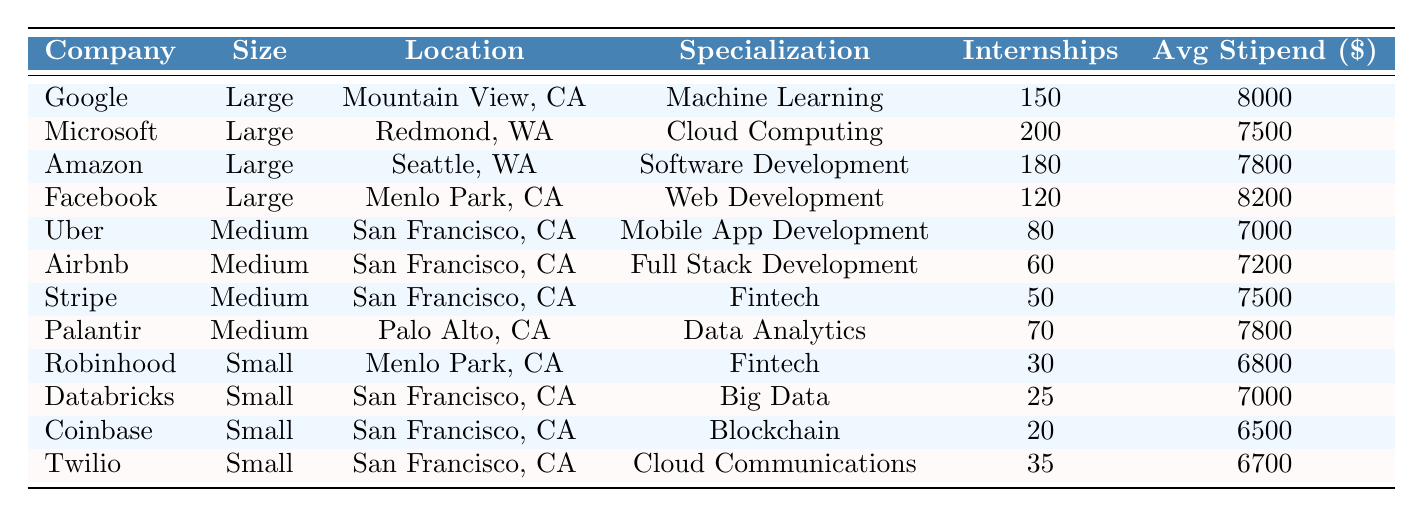What is the location of Microsoft? The table lists Microsoft as having a location in Redmond, WA.
Answer: Redmond, WA How many internships are available at Google? From the table, Google has 150 internships available.
Answer: 150 Which company has the highest average stipend? By checking the avg stipend column, Facebook has the highest stipend at $8200.
Answer: Facebook How many internships are offered by small companies in total? Adding the internships available by small companies: Robinhood (30) + Databricks (25) + Coinbase (20) + Twilio (35) = 110.
Answer: 110 Is there any company that specializes in both Fintech and is considered small? The table shows that Robinhood and Stripe are both small companies in Fintech.
Answer: Yes Which large company has the lowest average stipend? Comparing the average stipends of large companies, Microsoft has the lowest at $7500.
Answer: Microsoft What is the total number of internships available for medium-sized companies? The total for medium companies is Uber (80) + Airbnb (60) + Stripe (50) + Palantir (70) = 260 internships.
Answer: 260 What is the average stipend for internships in San Francisco? The companies located in San Francisco are Uber ($7000), Airbnb ($7200), Stripe ($7500), Databricks ($7000), Coinbase ($6500), and Twilio ($6700). The average is (7000 + 7200 + 7500 + 7000 + 6500 + 6700) / 6 = 6944.
Answer: 6944 Which location has the highest number of available internships? By checking the internship counts, Redmond (Microsoft) has the highest at 200.
Answer: Redmond, WA Is it true that all companies located in San Francisco are medium-sized? By examining the table, we see that not all companies in San Francisco are medium-sized; for example, Uber is also medium-sized, while some small companies like Twilio and Databricks are located there too.
Answer: No 